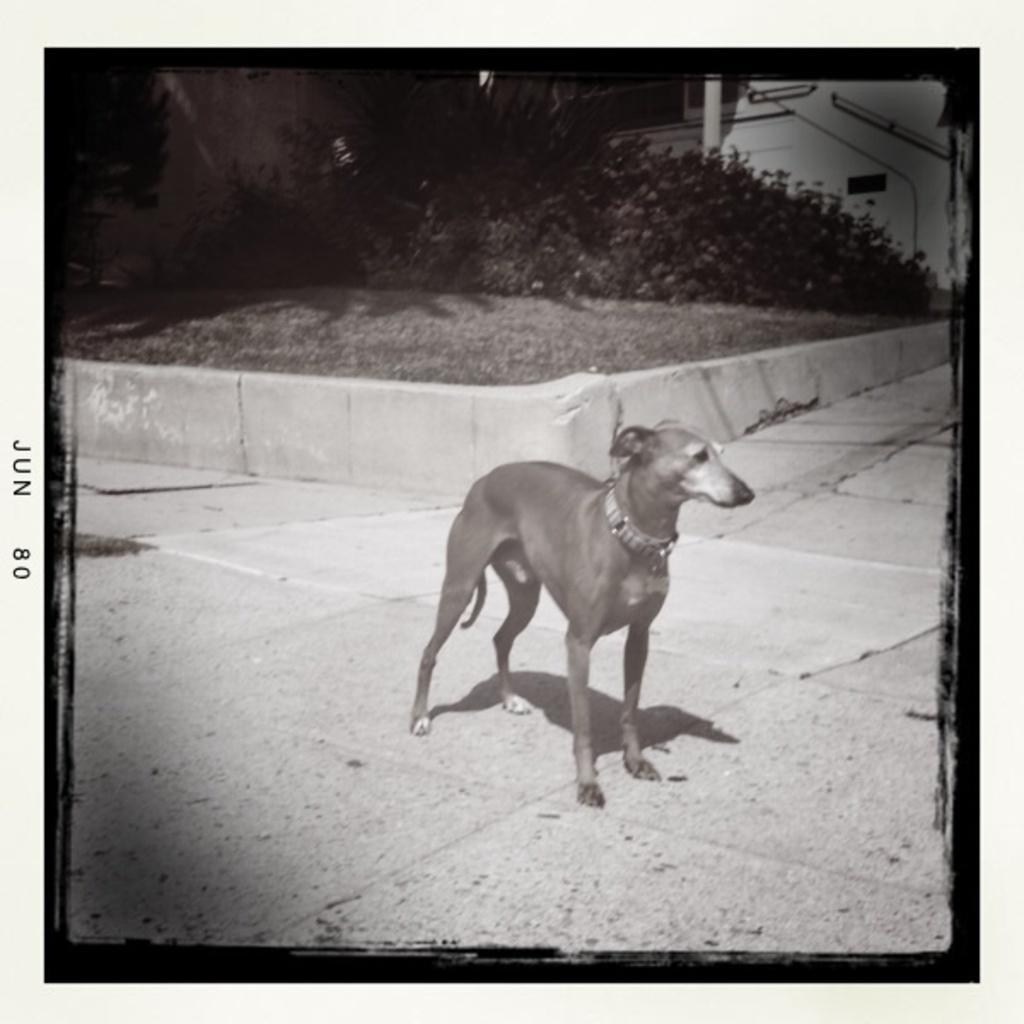How would you summarize this image in a sentence or two? This is a black and white image. In this image, in the middle, we can see a dog standing on the floor. In the background, we can see some trees, plants, pillars. 